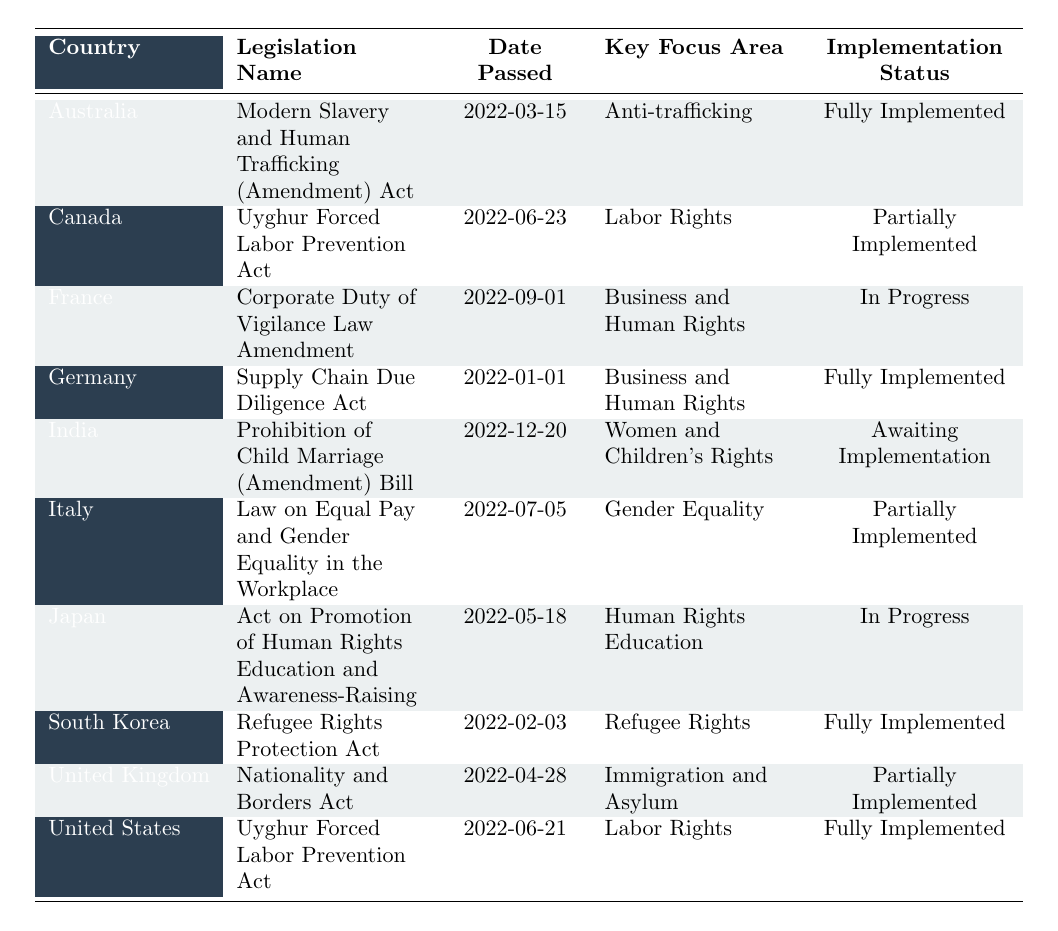What is the name of the legislation passed by Germany? The table indicates that Germany passed the "Supply Chain Due Diligence Act."
Answer: Supply Chain Due Diligence Act Which country passed legislation focused on Anti-trafficking? According to the table, Australia passed the "Modern Slavery and Human Trafficking (Amendment) Act," which focuses on Anti-trafficking.
Answer: Australia How many pieces of legislation are fully implemented? The table shows that there are four pieces of legislation under the "Fully Implemented" status: Australia's, Germany's, South Korea's, and the United States' acts.
Answer: 4 What was the key focus area of the legislation that India passed? According to the table, India's legislation, "Prohibition of Child Marriage (Amendment) Bill," focuses on Women and Children's Rights.
Answer: Women and Children's Rights Is the Uyghur Forced Labor Prevention Act in Canada fully implemented? The table states that the Uyghur Forced Labor Prevention Act in Canada is "Partially Implemented," not fully implemented.
Answer: No How does the implementation status of the Corporate Duty of Vigilance Law Amendment in France compare to that of the Law on Equal Pay in Italy? The table indicates that the Corporate Duty of Vigilance Law Amendment in France is "In Progress," while the Law on Equal Pay in Italy is "Partially Implemented," showing that Italy's legislation is further along than France's.
Answer: Italy's is more advanced Which countries have legislation focused on Labor Rights? From the table, Canada and the United States both have legislation focused on Labor Rights, specifically the "Uyghur Forced Labor Prevention Act."
Answer: Canada and United States What is the latest legislation passed concerning Women's Rights according to the table? The table lists India's "Prohibition of Child Marriage (Amendment) Bill," passed on 2022-12-20, as the latest concerning Women's Rights.
Answer: Prohibition of Child Marriage (Amendment) Bill Which country has the earliest passed legislation in the table? The table indicates that Germany's "Supply Chain Due Diligence Act," passed on 2022-01-01, is the earliest legislation among those listed.
Answer: Germany Which country has legislation still awaiting implementation? The table shows India's legislation, "Prohibition of Child Marriage (Amendment) Bill," is currently "Awaiting Implementation."
Answer: India 